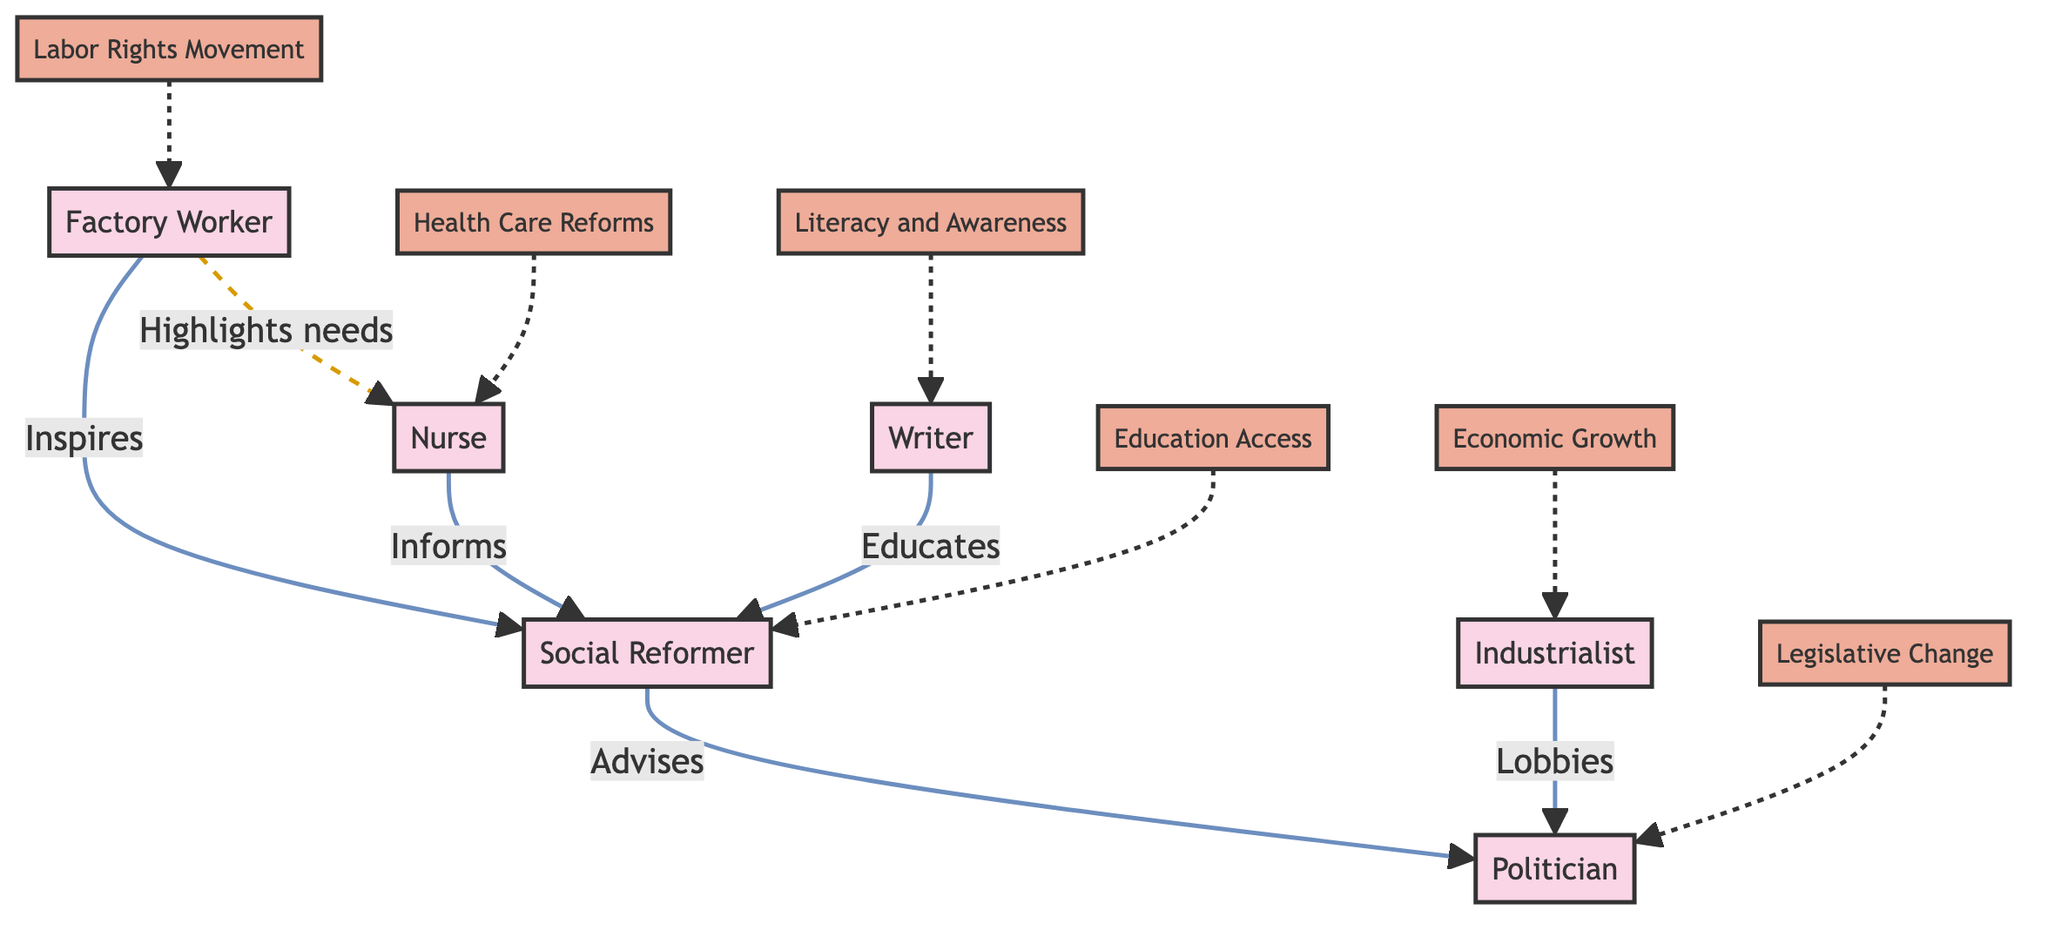What are the total number of nodes in the diagram? The diagram contains six nodes: Factory Worker, Social Reformer, Nurse, Writer, Politician, and Industrialist.
Answer: 6 Which occupation influences Health Care Reforms? According to the diagram, the Nurse is the occupation that influences Health Care Reforms.
Answer: Nurse What occupation connects with both Social Reformer and Health Care Reforms? The Factory Worker connects to the Social Reformer and highlights needs to the Nurse, who influences Health Care Reforms.
Answer: Factory Worker How many edges are in the diagram? There are six edges showing the relationships between the nodes in the diagram, such as connections between occupations and their influences.
Answer: 6 Which occupation advises the Politician? The Social Reformer advises the Politician according to the directed edge connected from B to E in the diagram.
Answer: Social Reformer Which node has multiple influences directed to it? The Social Reformer node has influences directed from Factory Worker, Nurse, and Writer nodes showing a collective impact on Education Access.
Answer: Social Reformer What type of influence does the Industrialist have on the Politician? The Industrialist lobbies the Politician according to the directed relationship indicated in the diagram.
Answer: Lobbies Which occupation does the Factory Worker directly connect with to inform health reforms? The Factory Worker connects with the Nurse, indirectly informing health reforms through this connection.
Answer: Nurse Which influence connects to the Writer? The influence that connects to the Writer is Literacy and Awareness as indicated in the diagram.
Answer: Literacy and Awareness 